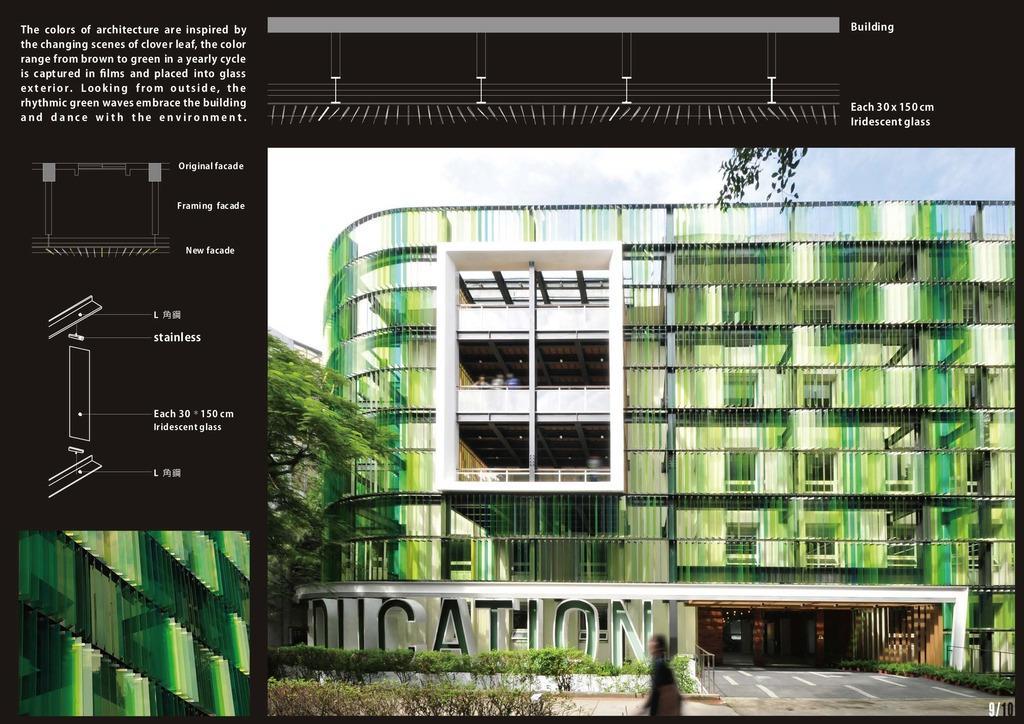Can you describe this image briefly? This is an edited image where there are plants, grass, building , a person , trees, sky and a watermark on the image. 